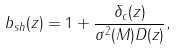<formula> <loc_0><loc_0><loc_500><loc_500>b _ { s h } ( z ) = 1 + \frac { \delta _ { c } ( z ) } { \sigma ^ { 2 } ( M ) D ( z ) } ,</formula> 